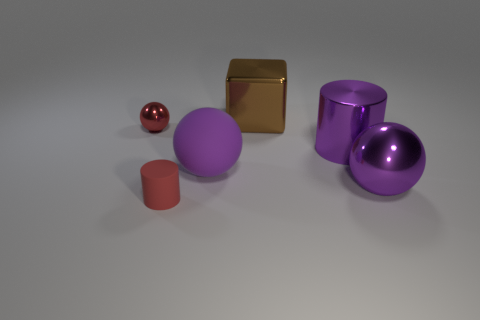Can you infer anything about the environment in which these objects are placed? The objects are positioned on a smooth, flat surface with a neutral color, which hints at a controlled environment possibly set up for the purpose of display or photography, given the uniform background and intentional placement of objects. 